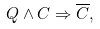<formula> <loc_0><loc_0><loc_500><loc_500>Q \wedge C \Rightarrow \overline { C } ,</formula> 